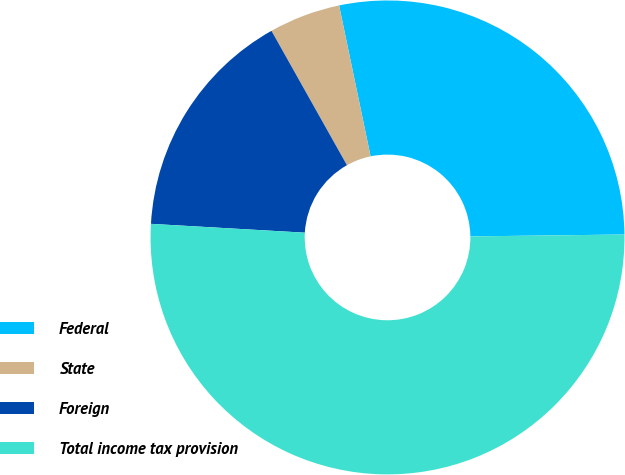Convert chart. <chart><loc_0><loc_0><loc_500><loc_500><pie_chart><fcel>Federal<fcel>State<fcel>Foreign<fcel>Total income tax provision<nl><fcel>28.08%<fcel>4.87%<fcel>15.94%<fcel>51.11%<nl></chart> 